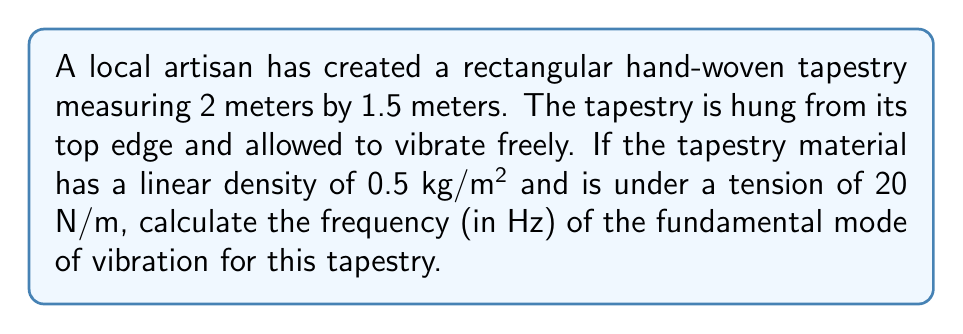Teach me how to tackle this problem. To solve this problem, we'll use the wave equation for a rectangular membrane:

1) The frequency of vibration for a rectangular membrane is given by:

   $$f = \frac{1}{2} \sqrt{\frac{T}{\mu}} \sqrt{\left(\frac{m}{a}\right)^2 + \left(\frac{n}{b}\right)^2}$$

   where:
   $f$ is the frequency
   $T$ is the tension per unit length
   $\mu$ is the mass per unit area
   $a$ and $b$ are the dimensions of the rectangle
   $m$ and $n$ are the mode numbers

2) For the fundamental mode, $m = 1$ and $n = 1$

3) Given:
   $T = 20$ N/m
   $\mu = 0.5$ kg/m²
   $a = 2$ m
   $b = 1.5$ m

4) Substituting these values:

   $$f = \frac{1}{2} \sqrt{\frac{20}{0.5}} \sqrt{\left(\frac{1}{2}\right)^2 + \left(\frac{1}{1.5}\right)^2}$$

5) Simplify:

   $$f = \frac{1}{2} \sqrt{40} \sqrt{0.25 + 0.4444}$$
   $$f = \frac{1}{2} \cdot 6.325 \cdot 0.8165$$

6) Calculate:

   $$f = 2.58$$ Hz (rounded to two decimal places)
Answer: 2.58 Hz 